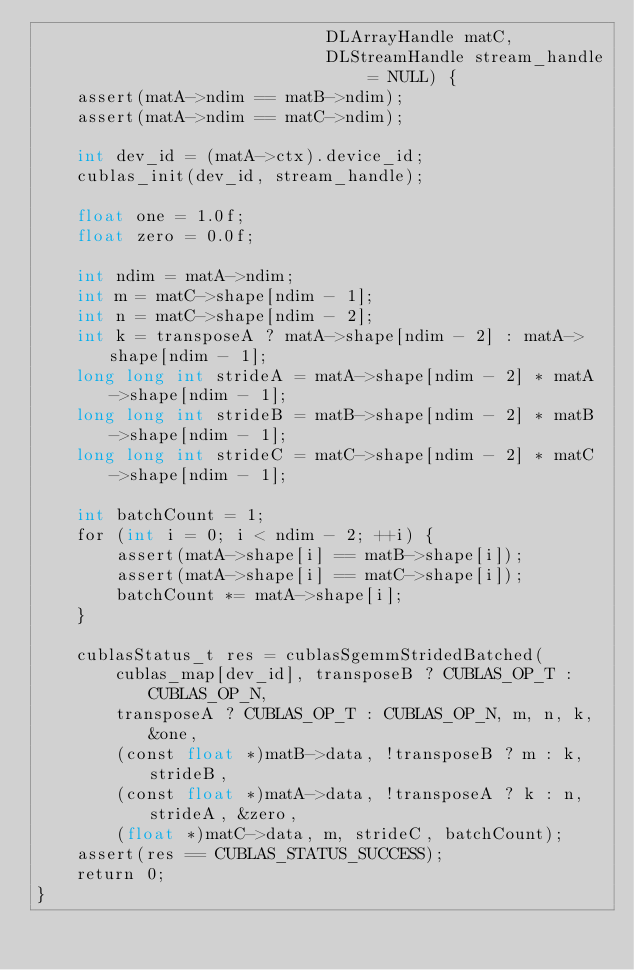Convert code to text. <code><loc_0><loc_0><loc_500><loc_500><_Cuda_>                             DLArrayHandle matC,
                             DLStreamHandle stream_handle = NULL) {
    assert(matA->ndim == matB->ndim);
    assert(matA->ndim == matC->ndim);

    int dev_id = (matA->ctx).device_id;
    cublas_init(dev_id, stream_handle);

    float one = 1.0f;
    float zero = 0.0f;

    int ndim = matA->ndim;
    int m = matC->shape[ndim - 1];
    int n = matC->shape[ndim - 2];
    int k = transposeA ? matA->shape[ndim - 2] : matA->shape[ndim - 1];
    long long int strideA = matA->shape[ndim - 2] * matA->shape[ndim - 1];
    long long int strideB = matB->shape[ndim - 2] * matB->shape[ndim - 1];
    long long int strideC = matC->shape[ndim - 2] * matC->shape[ndim - 1];

    int batchCount = 1;
    for (int i = 0; i < ndim - 2; ++i) {
        assert(matA->shape[i] == matB->shape[i]);
        assert(matA->shape[i] == matC->shape[i]);
        batchCount *= matA->shape[i];
    }

    cublasStatus_t res = cublasSgemmStridedBatched(
        cublas_map[dev_id], transposeB ? CUBLAS_OP_T : CUBLAS_OP_N,
        transposeA ? CUBLAS_OP_T : CUBLAS_OP_N, m, n, k, &one,
        (const float *)matB->data, !transposeB ? m : k, strideB,
        (const float *)matA->data, !transposeA ? k : n, strideA, &zero,
        (float *)matC->data, m, strideC, batchCount);
    assert(res == CUBLAS_STATUS_SUCCESS);
    return 0;
}
</code> 